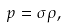Convert formula to latex. <formula><loc_0><loc_0><loc_500><loc_500>p = \sigma \rho ,</formula> 